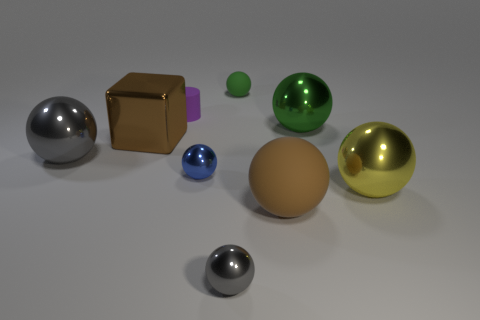What is the shape of the large metal thing that is the same color as the large rubber sphere?
Ensure brevity in your answer.  Cube. Do the purple rubber cylinder and the brown rubber thing have the same size?
Give a very brief answer. No. Are there any rubber cylinders to the right of the matte ball that is in front of the big ball on the left side of the small green matte object?
Your response must be concise. No. What is the size of the green rubber ball?
Provide a succinct answer. Small. What number of rubber objects are the same size as the cylinder?
Provide a succinct answer. 1. What is the material of the large yellow object that is the same shape as the big gray metal object?
Make the answer very short. Metal. The big thing that is both on the right side of the brown shiny object and behind the small blue metallic ball has what shape?
Your response must be concise. Sphere. There is a gray thing that is on the left side of the blue object; what shape is it?
Give a very brief answer. Sphere. What number of things are right of the big gray thing and left of the big yellow metallic sphere?
Provide a short and direct response. 7. There is a cube; is its size the same as the gray sphere in front of the brown rubber object?
Provide a short and direct response. No. 